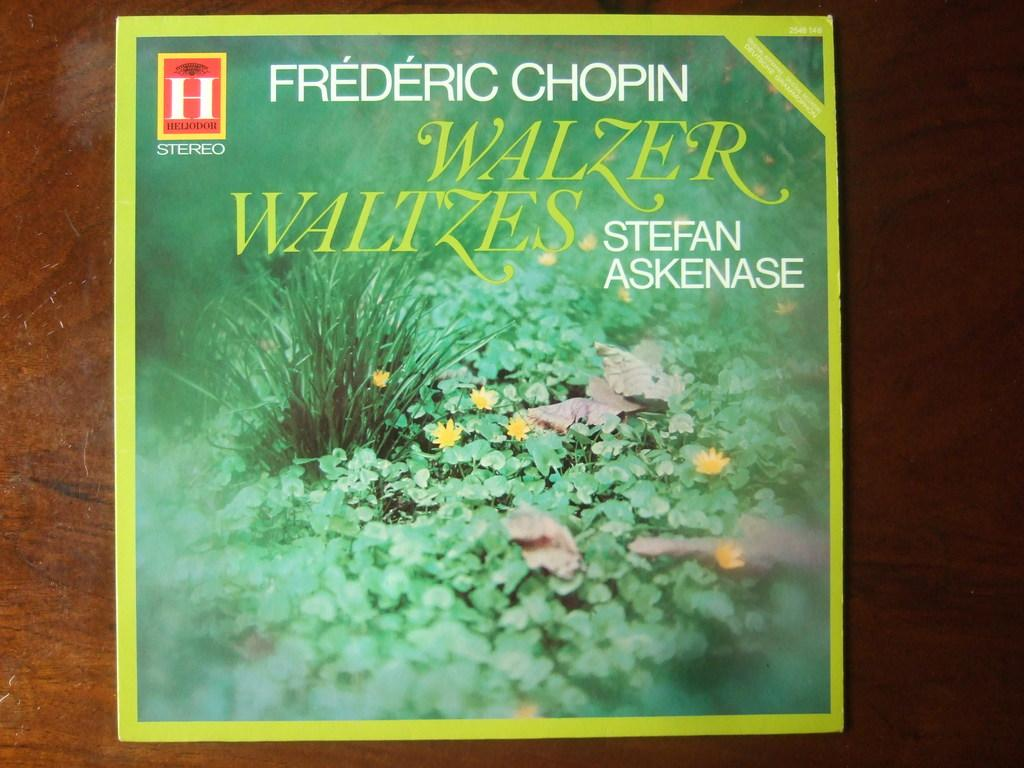<image>
Describe the image concisely. A record album showing a field of green grass and yellow flowers containing music composed by Chopin. 